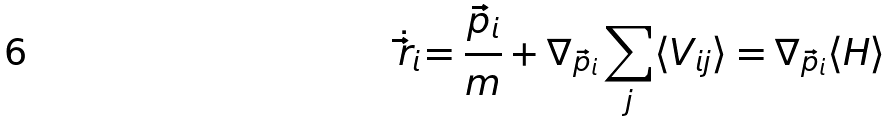<formula> <loc_0><loc_0><loc_500><loc_500>\dot { \vec { r } _ { i } } = { \frac { \vec { p } _ { i } } { m } } + \nabla _ { \vec { p } _ { i } } \sum _ { j } \langle V _ { i j } \rangle = \nabla _ { \vec { p } _ { i } } \langle H \rangle</formula> 